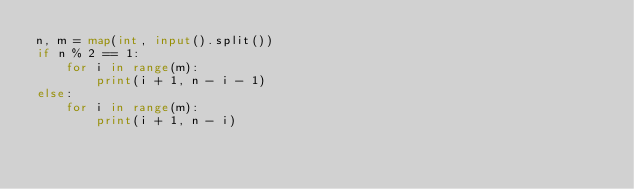<code> <loc_0><loc_0><loc_500><loc_500><_Python_>n, m = map(int, input().split())
if n % 2 == 1:
    for i in range(m):
        print(i + 1, n - i - 1)
else:
    for i in range(m):
        print(i + 1, n - i)</code> 